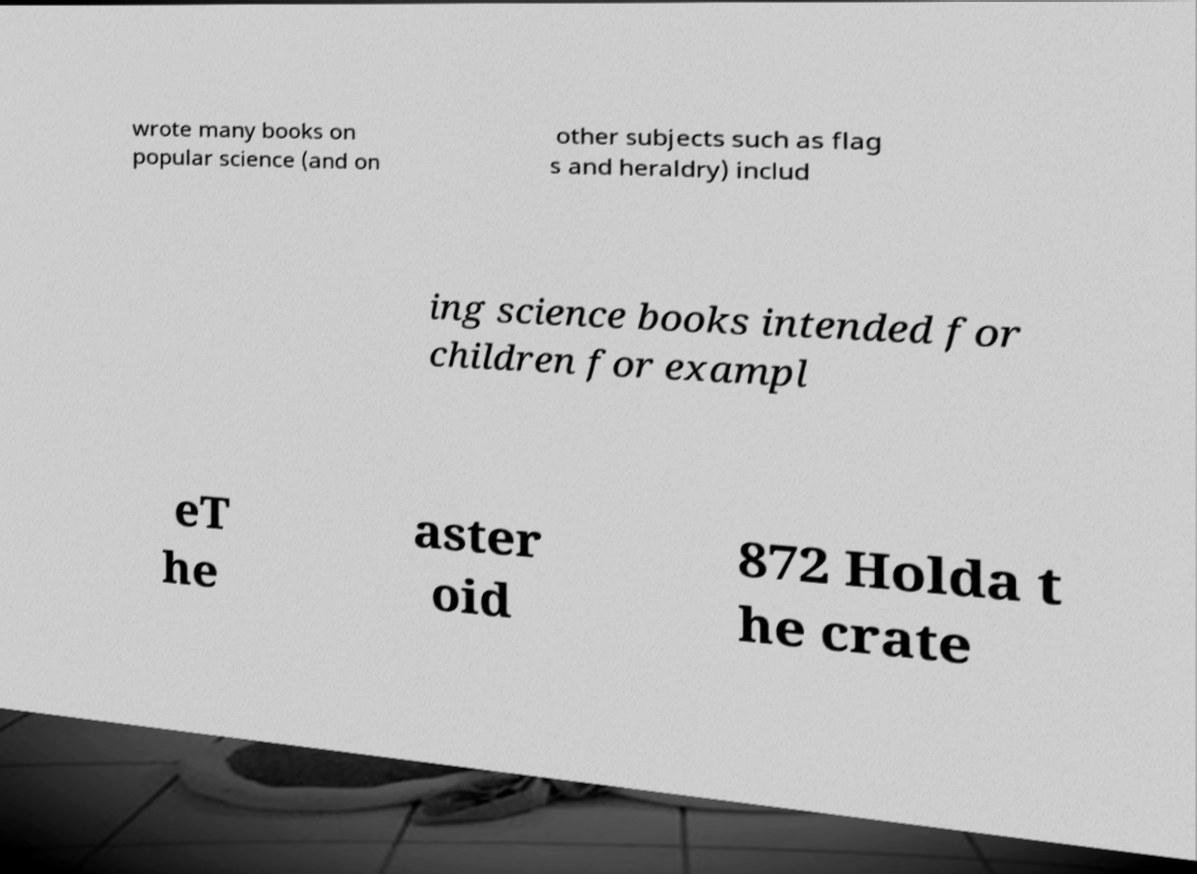I need the written content from this picture converted into text. Can you do that? wrote many books on popular science (and on other subjects such as flag s and heraldry) includ ing science books intended for children for exampl eT he aster oid 872 Holda t he crate 